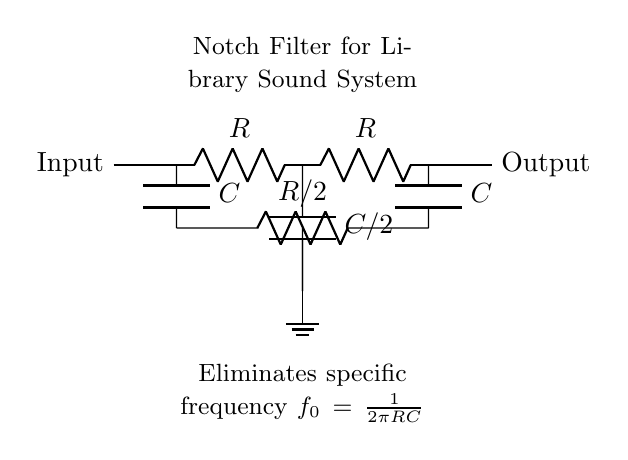What is the input component in this circuit? The input component is a short wire connecting to the first resistive element, labeled as Input.
Answer: short wire What type of components are used in this notch filter? The circuit uses resistors and capacitors arranged in a specific configuration to form the notch filter.
Answer: resistors and capacitors What is the formula for the specific frequency eliminated by the filter? The specific frequency, denoted as f_0, is calculated using the formula f_0 = 1/(2πRC), where R is the resistance and C is the capacitance in the circuit.
Answer: 1/(2πRC) How many capacitors are in this circuit? The circuit contains a total of three capacitors; one in the upper path and two in the lower path.
Answer: three What role do the resistors play in this notch filter circuit? The resistors in the circuit determine the frequency characteristics by affecting the filtering capabilities and the cutoff frequency when paired with the capacitors.
Answer: determining frequency characteristics Which component is connected to ground in this circuit? The lower capacitor, labeled as C/2, is the component that is directly connected to the ground.
Answer: capacitor C/2 